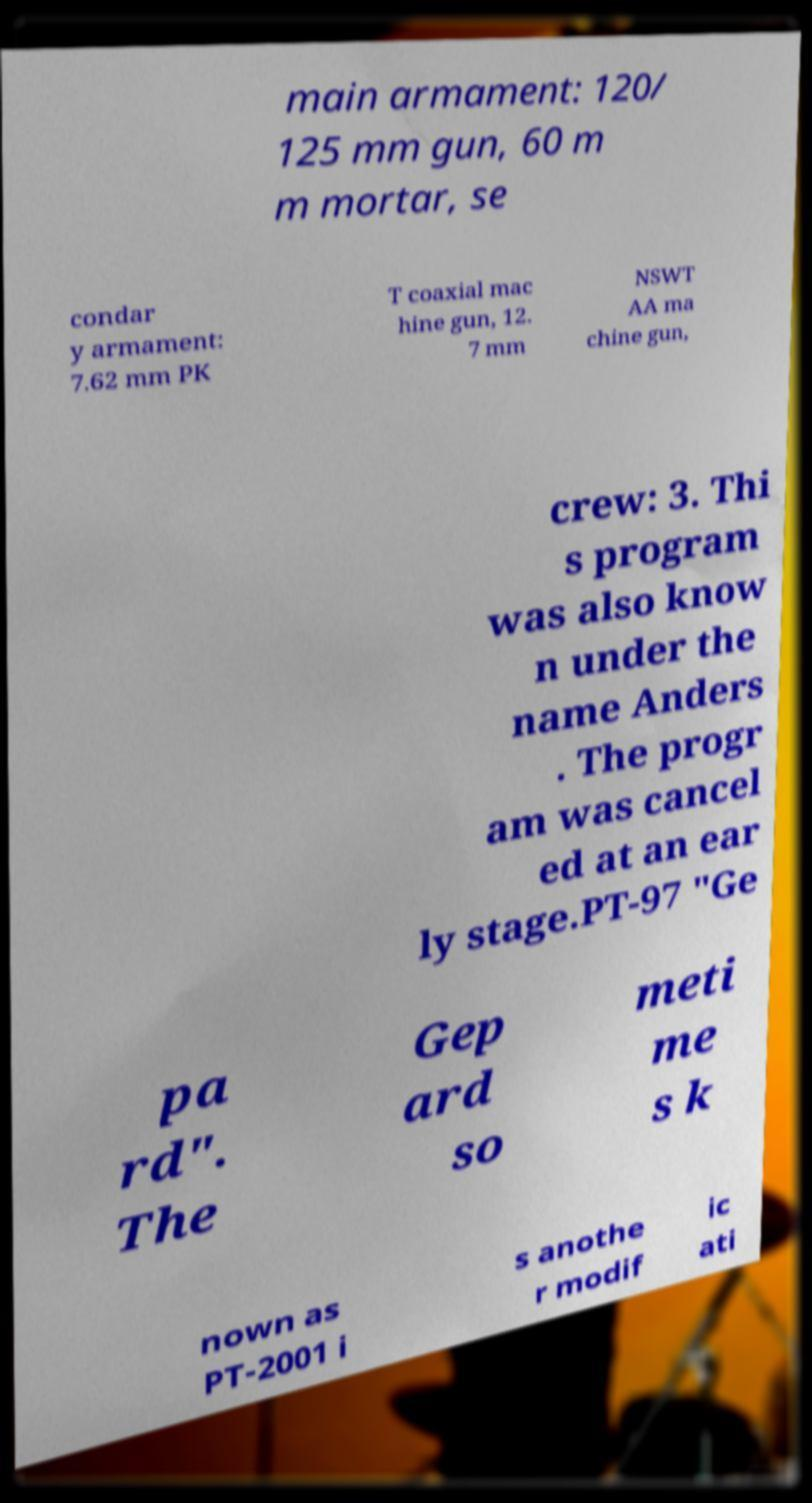For documentation purposes, I need the text within this image transcribed. Could you provide that? main armament: 120/ 125 mm gun, 60 m m mortar, se condar y armament: 7.62 mm PK T coaxial mac hine gun, 12. 7 mm NSWT AA ma chine gun, crew: 3. Thi s program was also know n under the name Anders . The progr am was cancel ed at an ear ly stage.PT-97 "Ge pa rd". The Gep ard so meti me s k nown as PT-2001 i s anothe r modif ic ati 